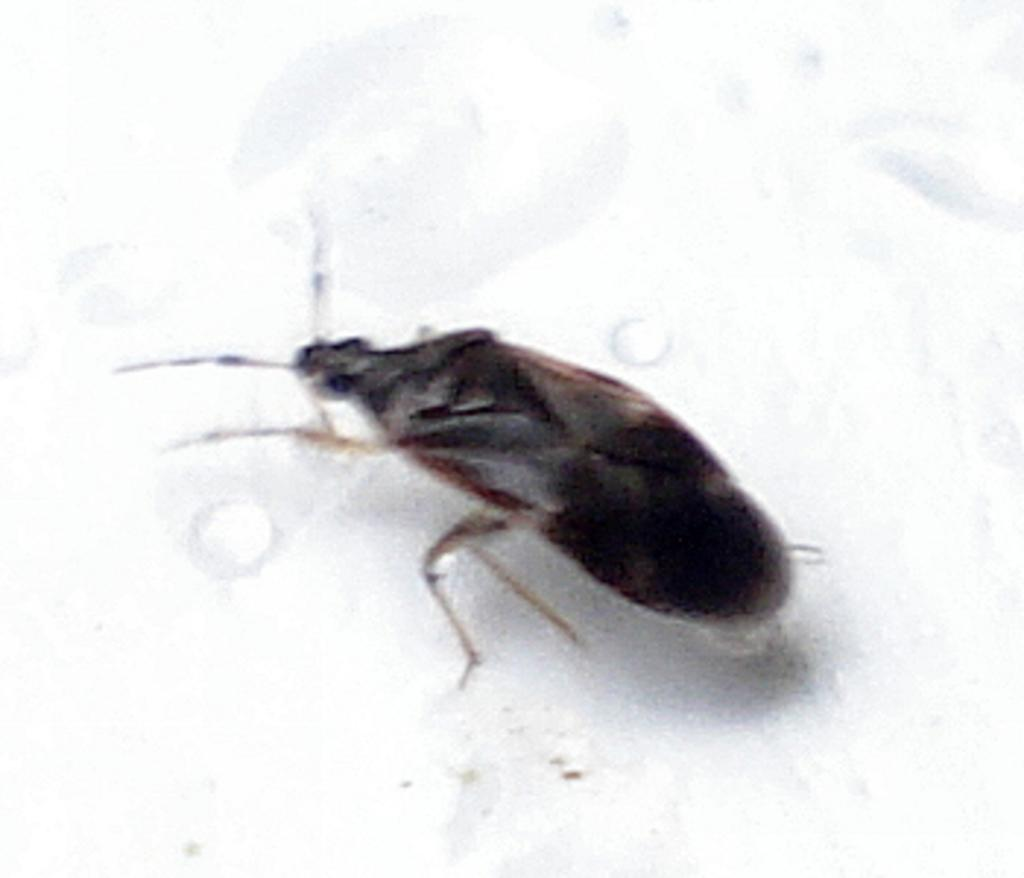What type of creature can be seen in the image? There is an insect in the image. What is the insect doing in the image? The insect is standing on top of an object. Can you see a hose being used to water the plants in the image? There is no hose or plants visible in the image; it only features an insect standing on top of an object. 